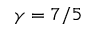Convert formula to latex. <formula><loc_0><loc_0><loc_500><loc_500>\gamma = 7 / 5</formula> 